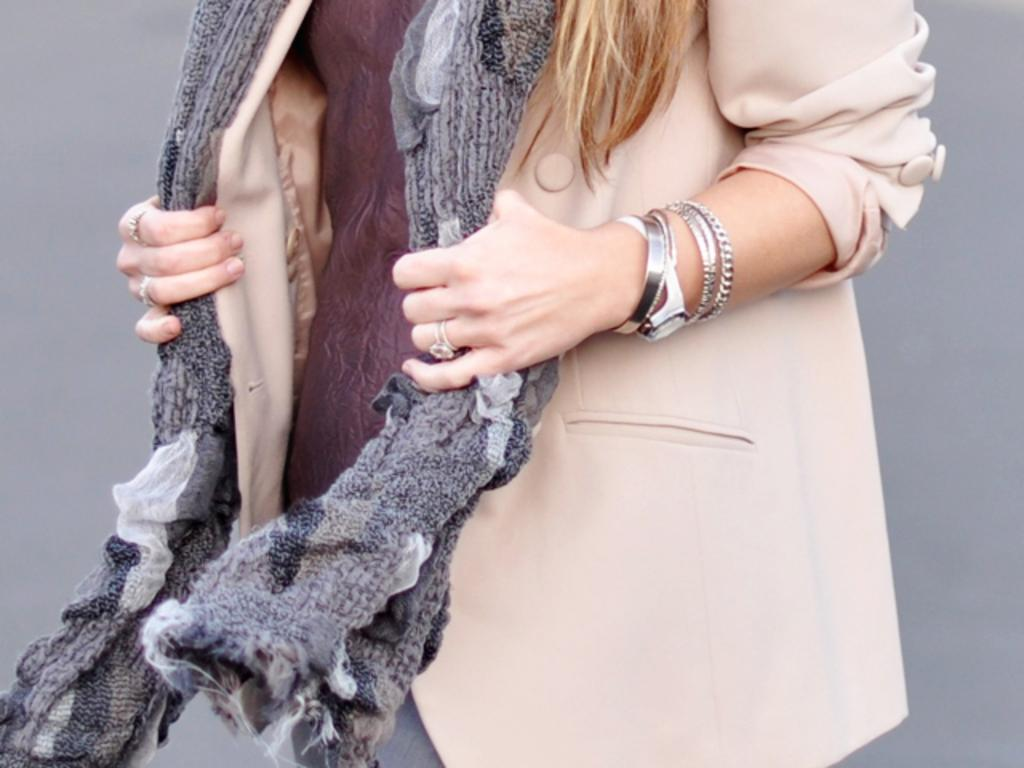Who is the main subject in the image? There is a lady in the image. What accessories is the lady wearing? The lady is wearing a watch, bangles, and rings. What type of clothing is the lady wearing? The lady is wearing a shawl. What can be seen in the background of the image? There is a wall in the background of the image. What type of turkey is the lady preparing in the image? There is no turkey present in the image, nor is the lady preparing any food. What is the lady writing on the wall in the image? The lady is not writing on the wall in the image; there is no writing or text visible. 